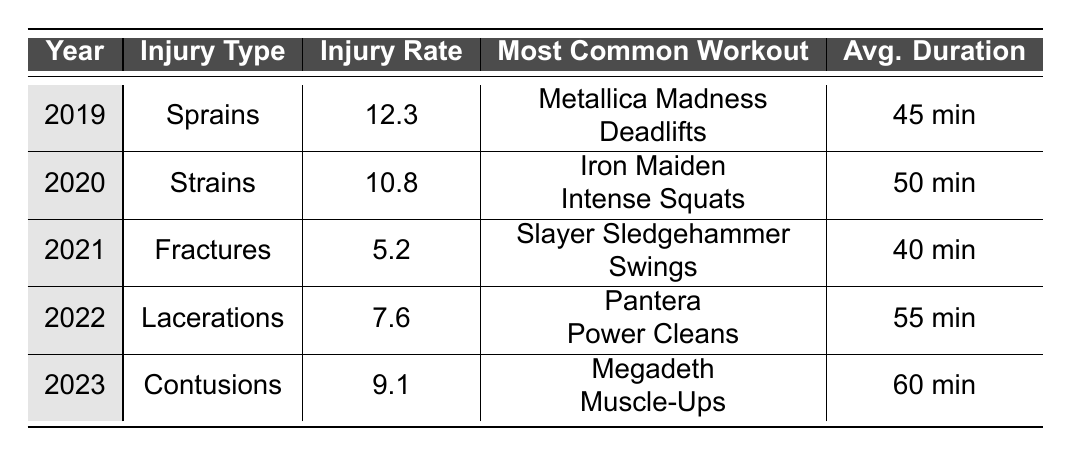What was the injury rate for Sprains in 2019? The table shows that in 2019, the injury rate for Sprains was 12.3 per 1000 workers.
Answer: 12.3 Which workout had the highest injury rate in the table? The workout with the highest injury rate is "Metallica Madness Deadlifts" from 2019, where the injury rate was 12.3 per 1000 workers.
Answer: Metallica Madness Deadlifts In which year did the injury rate for Fractures reach its lowest point? The data indicates that the injury rate for Fractures in 2021 was 5.2 per 1000 workers, which is the lowest point for any injury type listed in the table.
Answer: 2021 What is the average injury rate across all years listed in the table? To find the average injury rate, sum the injury rates (12.3 + 10.8 + 5.2 + 7.6 + 9.1 = 45) and divide by 5 (the number of years), which gives 45/5 = 9.0.
Answer: 9.0 Did the injury rate for Strains increase or decrease from 2019 to 2020? Comparing the year 2019 (Sprains at 12.3) to 2020 (Strains at 10.8), the rate decreased by 1.5.
Answer: Decrease What is the total injury rate for all types from 2019 to 2023? The total injury rate is found by summing each year's rate: 12.3 + 10.8 + 5.2 + 7.6 + 9.1 = 45. The total injury rate for 2019 to 2023 is 45.
Answer: 45 Which injury type had the longest average workout duration, and how long was it? By comparing the average workout durations, "Megadeth Muscle-Ups" in 2023 had the longest duration at 60 minutes.
Answer: Megadeth Muscle-Ups, 60 minutes How does the injury rate for Contusions in 2023 compare to that for Lacerations in 2022? The injury rate for Contusions in 2023 was 9.1, while for Lacerations in 2022 it was 7.6. Therefore, the injury rate for Contusions is higher by (9.1 - 7.6 = 1.5).
Answer: Higher by 1.5 Is it true that Iron Maiden Intense Squats had a higher injury rate than Slayer Sledgehammer Swings? Yes, Iron Maiden Intense Squats had an injury rate of 10.8 in 2020 compared to Slayer Sledgehammer Swings which had a rate of 5.2 in 2021.
Answer: True What was the change in injury rate from 2020 to 2021, and was it an increase or decrease? The injury rate decreased from 10.8 (Strains in 2020) to 5.2 (Fractures in 2021), a change of 5.6.
Answer: Decrease by 5.6 